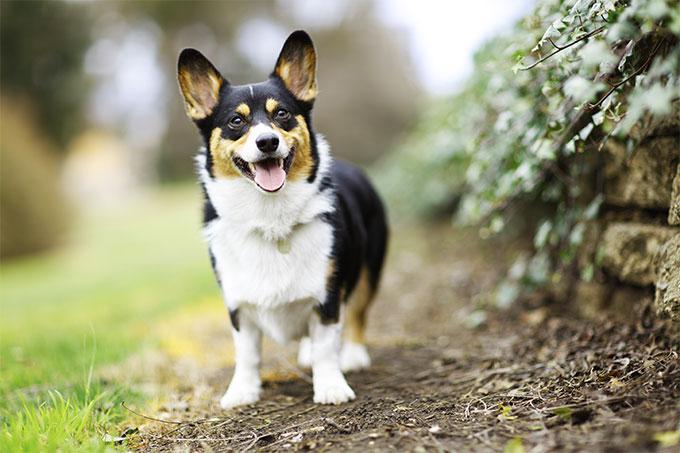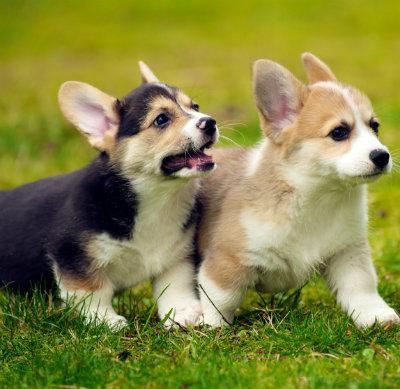The first image is the image on the left, the second image is the image on the right. Examine the images to the left and right. Is the description "At least one dog is showing its tongue." accurate? Answer yes or no. Yes. The first image is the image on the left, the second image is the image on the right. For the images displayed, is the sentence "Both images contain a single camera-facing dog, and both images contain tri-color black, white and tan dogs." factually correct? Answer yes or no. No. 